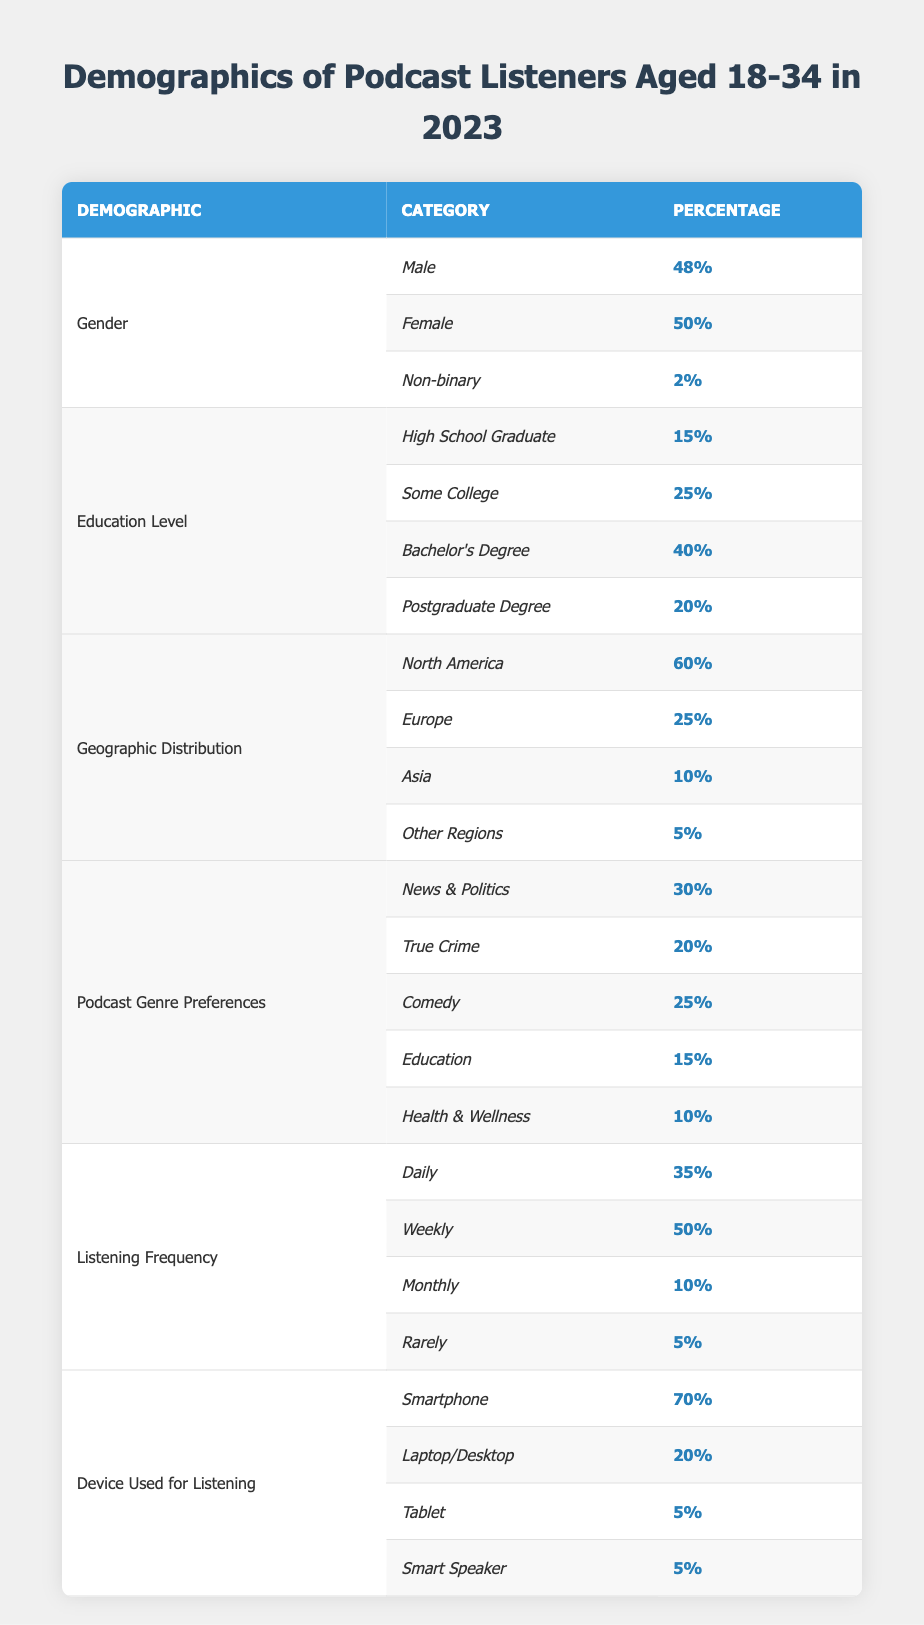What percentage of podcast listeners aged 18-34 are Female? The table indicates that the percentage of Female podcast listeners is 50%.
Answer: 50% What is the total percentage of listeners with a Bachelor's Degree or higher? Adding the percentages of Bachelor's Degree (40%) and Postgraduate Degree (20%) gives us 40% + 20% = 60%.
Answer: 60% Is the majority of podcast listeners in this age group from North America? The table shows that 60% of the demographic is from North America, which is more than half, confirming that it is the majority.
Answer: Yes What percentage of listeners prefer News & Politics over True Crime? The preference for News & Politics is 30%, while it is 20% for True Crime. Subtracting 20% from 30% gives us 30% - 20% = 10%.
Answer: 10% What is the percentage of podcast listeners who listen monthly or rarely? The percentage of Monthly listeners is 10%, and those who listen Rarely is 5%. Adding these percentages results in 10% + 5% = 15%.
Answer: 15% Which device is most commonly used for listening? The table displays that 70% of listeners use a Smartphone, more than any other device.
Answer: Smartphone How does the percentage of listeners who identify as Non-binary compare to those who graduated from high school? Non-binary listeners make up 2%, while High School Graduates are 15%. Comparing these values shows that 2% is less than 15%.
Answer: Non-binary listeners are less What percentage of listeners are either Daily or Weekly? The Daily listeners account for 35%, and the Weekly listeners for 50%. Adding these values gives 35% + 50% = 85%.
Answer: 85% What is the difference in the percentage of listeners between Comedy and Education genres? The percentage for Comedy is 25% and for Education is 15%. The difference is 25% - 15% = 10%.
Answer: 10% If you add the percentages of some college and postgraduate degrees, what total do you get? The percentage for Some College is 25% and for Postgraduate Degree is 20%. Summing these values results in 25% + 20% = 45%.
Answer: 45% 